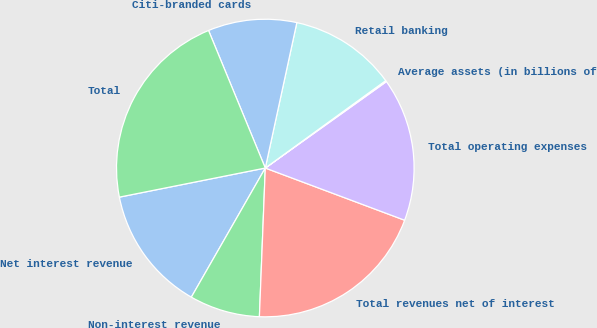Convert chart. <chart><loc_0><loc_0><loc_500><loc_500><pie_chart><fcel>Net interest revenue<fcel>Non-interest revenue<fcel>Total revenues net of interest<fcel>Total operating expenses<fcel>Average assets (in billions of<fcel>Retail banking<fcel>Citi-branded cards<fcel>Total<nl><fcel>13.59%<fcel>7.65%<fcel>19.93%<fcel>15.57%<fcel>0.13%<fcel>11.61%<fcel>9.63%<fcel>21.91%<nl></chart> 